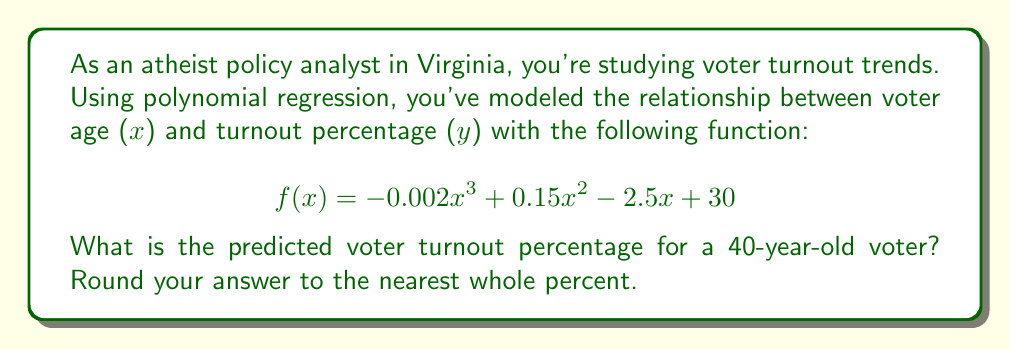What is the answer to this math problem? To solve this problem, we need to evaluate the given polynomial function at x = 40. Let's break it down step-by-step:

1. The given function is:
   $$f(x) = -0.002x^3 + 0.15x^2 - 2.5x + 30$$

2. Substitute x = 40 into the function:
   $$f(40) = -0.002(40)^3 + 0.15(40)^2 - 2.5(40) + 30$$

3. Calculate each term:
   a. $-0.002(40)^3 = -0.002 * 64000 = -128$
   b. $0.15(40)^2 = 0.15 * 1600 = 240$
   c. $-2.5(40) = -100$
   d. The constant term is 30

4. Sum up all the terms:
   $$f(40) = -128 + 240 - 100 + 30 = 42$$

5. Round to the nearest whole percent:
   42 rounds to 42%

Therefore, the predicted voter turnout percentage for a 40-year-old voter is 42%.
Answer: 42% 